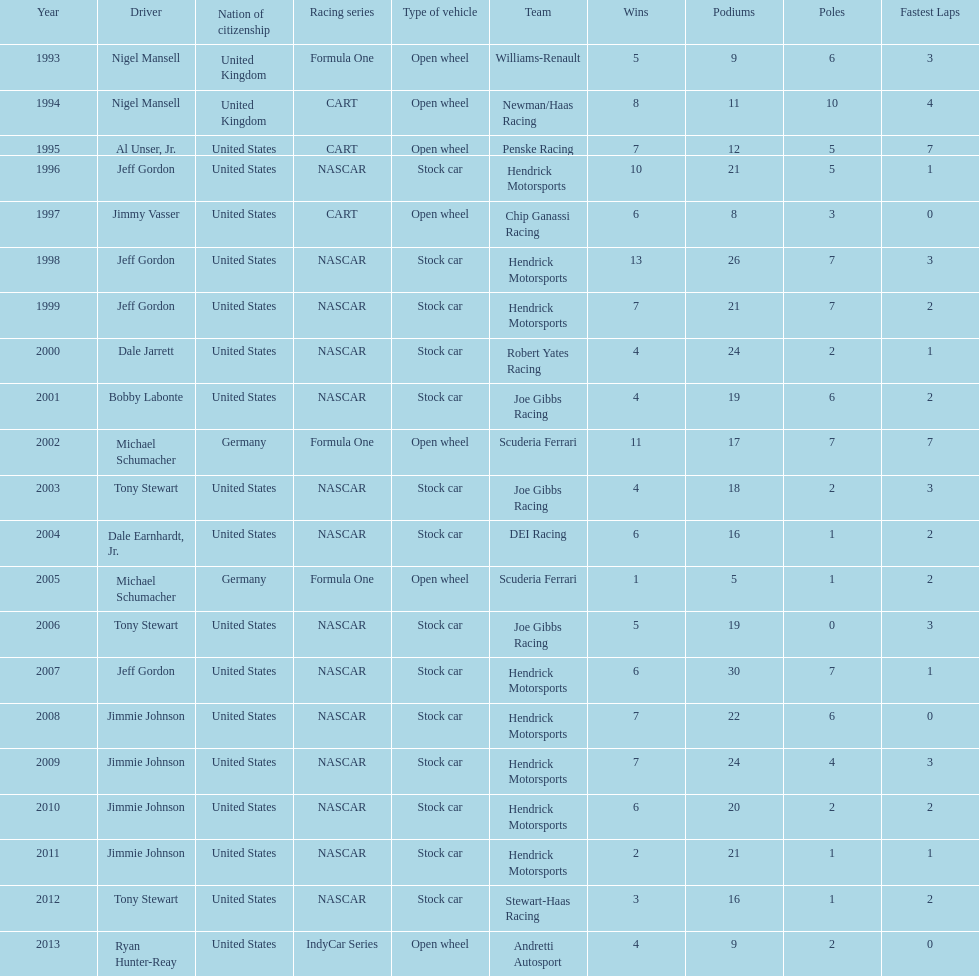How many times did jeff gordon win the award? 4. 